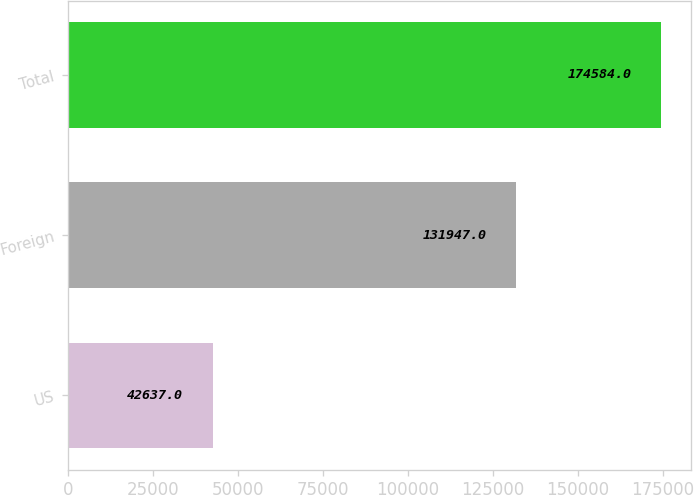<chart> <loc_0><loc_0><loc_500><loc_500><bar_chart><fcel>US<fcel>Foreign<fcel>Total<nl><fcel>42637<fcel>131947<fcel>174584<nl></chart> 